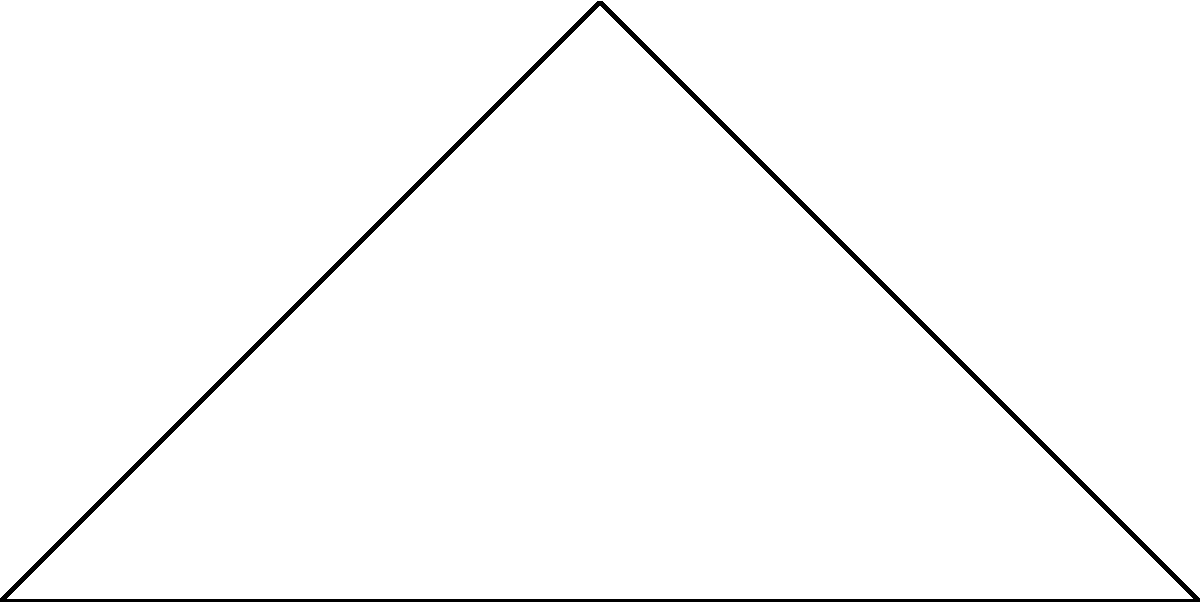During a business trip to a research facility studying non-Euclidean geometry, you encounter a triangle drawn on a hyperbolic plane. The angles of this triangle are labeled $\alpha$, $\beta$, and $\gamma$. You recall that in hyperbolic geometry, the sum of the angles in a triangle is always less than 180°. If $\alpha = 45°$ and $\beta = 60°$, what is the maximum possible value for $\gamma$? Let's approach this step-by-step:

1) In Euclidean geometry, we know that the sum of angles in a triangle is always 180°. However, in hyperbolic geometry, this sum is always less than 180°.

2) We can express this mathematically as:

   $$\alpha + \beta + \gamma < 180°$$

3) We are given that $\alpha = 45°$ and $\beta = 60°$. Let's substitute these values:

   $$45° + 60° + \gamma < 180°$$

4) Simplify:

   $$105° + \gamma < 180°$$

5) To find the maximum possible value for $\gamma$, we need to consider the strict inequality. The largest value $\gamma$ can take is just slightly less than the difference between 180° and 105°:

   $$\gamma < 180° - 105°$$
   $$\gamma < 75°$$

6) Therefore, the maximum value for $\gamma$ would be infinitesimally less than 75°, which we can express as 75° - ε, where ε is an infinitesimally small positive number.
Answer: 75° - ε (where ε > 0 and infinitesimally small) 